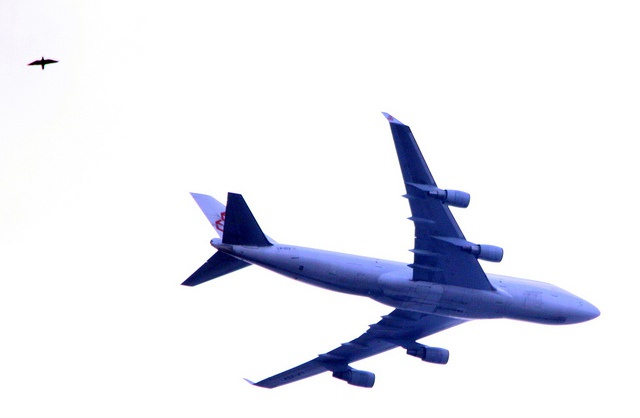Describe the objects in this image and their specific colors. I can see airplane in lavender, navy, lightblue, white, and blue tones and bird in white, black, magenta, and darkgreen tones in this image. 